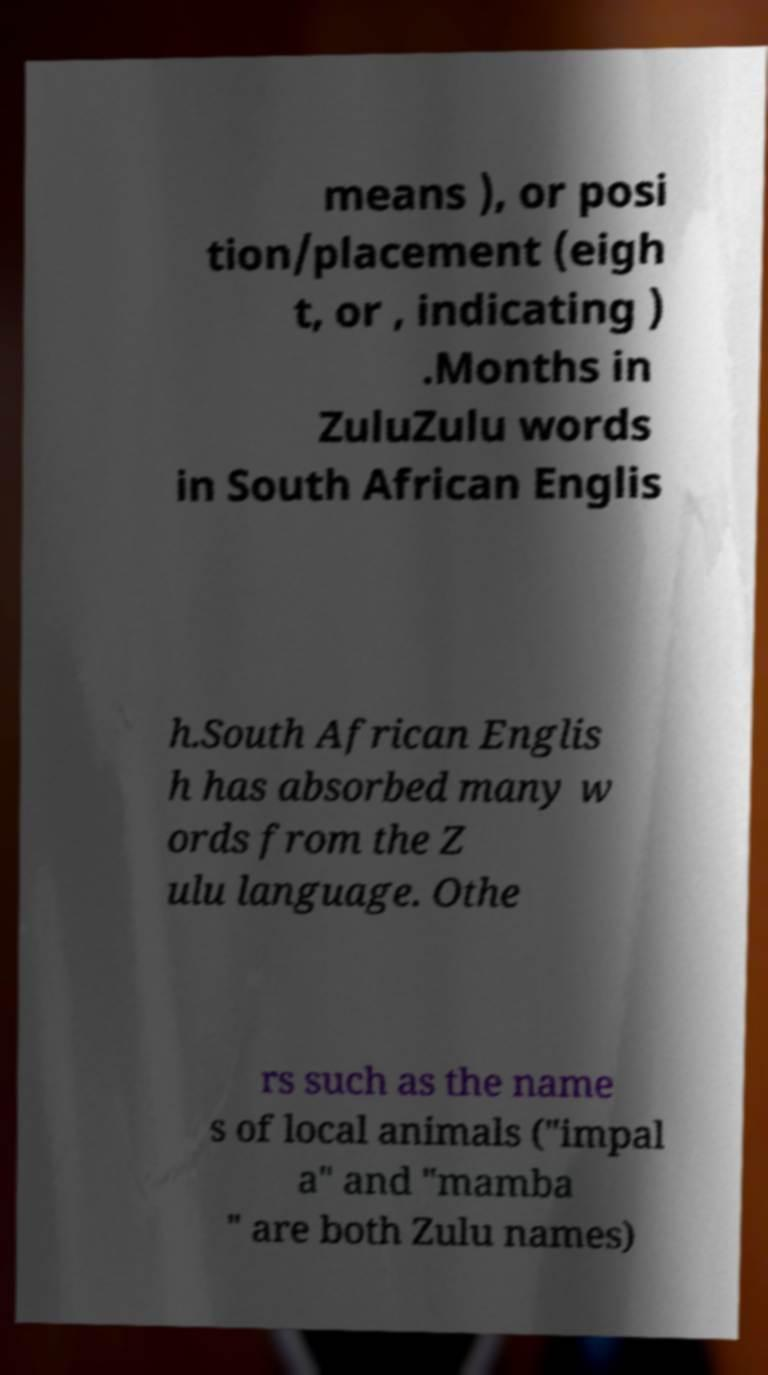There's text embedded in this image that I need extracted. Can you transcribe it verbatim? means ), or posi tion/placement (eigh t, or , indicating ) .Months in ZuluZulu words in South African Englis h.South African Englis h has absorbed many w ords from the Z ulu language. Othe rs such as the name s of local animals ("impal a" and "mamba " are both Zulu names) 